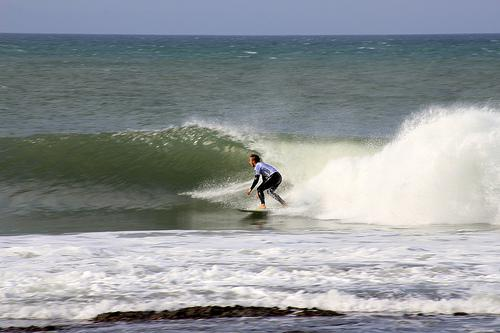Question: what color are the waves?
Choices:
A. Blue.
B. Green.
C. Black.
D. White.
Answer with the letter. Answer: D Question: what is the man doing?
Choices:
A. Picking his nose.
B. Scratching his butt.
C. Surfing.
D. Reading a newspaper.
Answer with the letter. Answer: C Question: where was this picture taken?
Choices:
A. The ocean.
B. The park.
C. The carnival.
D. The school.
Answer with the letter. Answer: A Question: who is in the picture?
Choices:
A. A Grandma.
B. A sister.
C. A man.
D. Me.
Answer with the letter. Answer: C Question: how is the weather?
Choices:
A. Sunny.
B. Cold.
C. Humid.
D. Hot.
Answer with the letter. Answer: A Question: what color is the man's shirt?
Choices:
A. White.
B. Blue.
C. Red.
D. Green.
Answer with the letter. Answer: B Question: what color is the sky?
Choices:
A. Blue.
B. Grey.
C. White.
D. Black.
Answer with the letter. Answer: A 